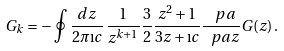<formula> <loc_0><loc_0><loc_500><loc_500>G _ { k } = - \oint \frac { d z } { 2 \pi \i c } \, \frac { 1 } { z ^ { k + 1 } } \frac { 3 } { 2 } \frac { z ^ { 2 } + 1 } { 3 z + \i c } \frac { \ p a } { \ p a z } G ( z ) \, .</formula> 